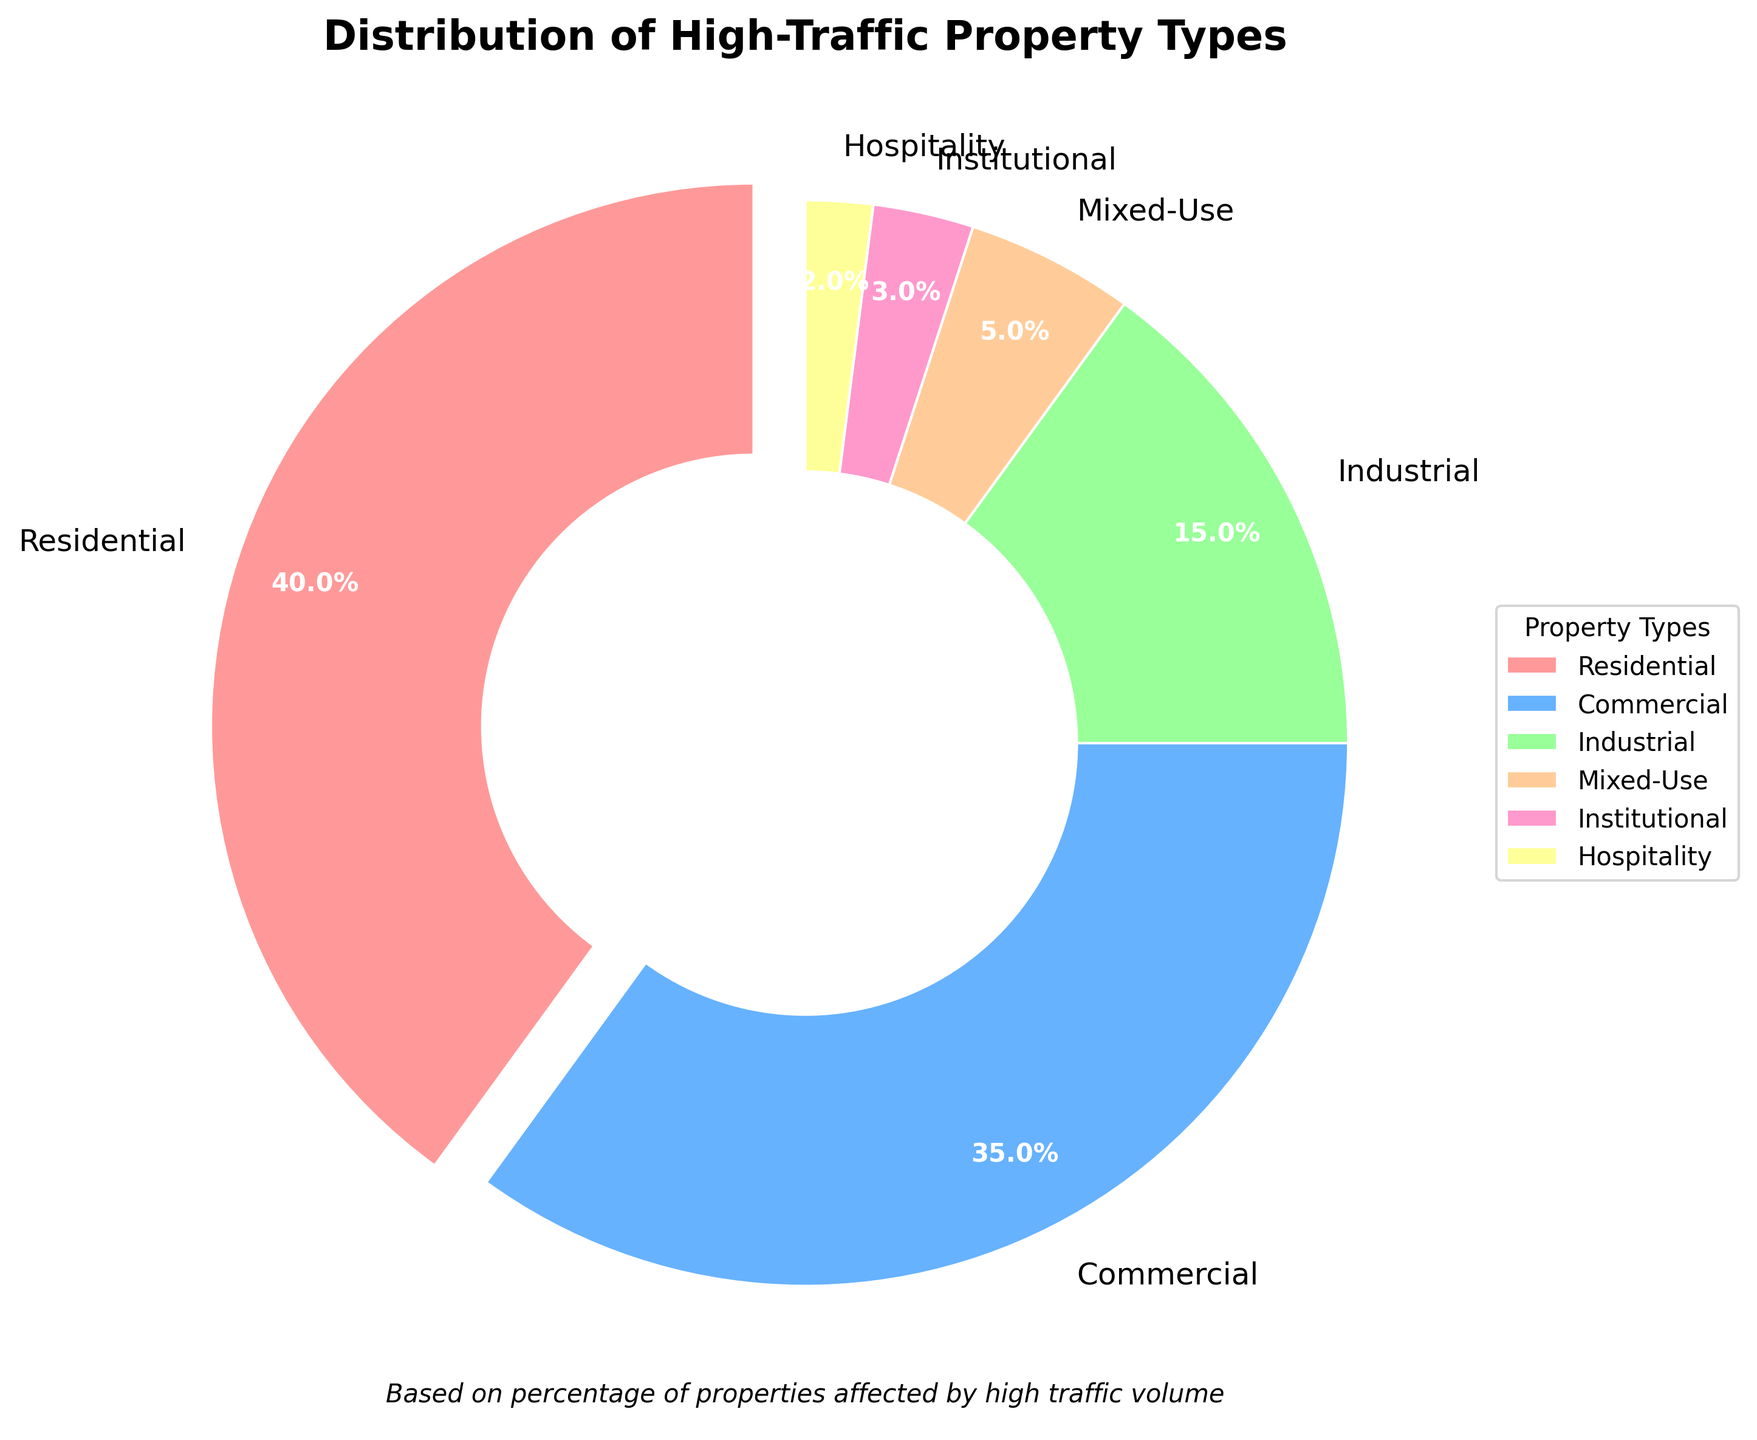What is the largest segment in the pie chart? The largest segment in the pie chart is the one with the highest percentage. By visually inspecting the figure, the segment labeled "Residential" occupies the largest area, which equals 40%.
Answer: Residential Which property type has the smallest percentage? The smallest segment on the pie chart is the one with the smallest percentage. Looking closely at the pie chart, the segment labeled "Hospitality" has the smallest size, which corresponds to 2%.
Answer: Hospitality How much greater is the percentage of Residential properties compared to Industrial properties? To find how much greater the Residential percentage is compared to Industrial, subtract the percentage of Industrial (15%) from Residential (40%). That is, 40% - 15% = 25%.
Answer: 25% What is the sum of the percentages for Commercial and Mixed-Use properties? To find the sum, add the percentage of Commercial (35%) and Mixed-Use (5%). So, 35% + 5% = 40%.
Answer: 40% Between Institutional and Hospitality properties, which has a higher percentage and by how much? Comparing the percentages for Institutional (3%) and Hospitality (2%), Institutional has a higher percentage. Subtract Hospitality's percentage from Institutional's to get the difference: 3% - 2% = 1%.
Answer: Institutional, 1% What is the percentage difference between the two leading property types? The two leading property types are Residential (40%) and Commercial (35%). Subtract the percentage of Commercial from Residential: 40% - 35% = 5%.
Answer: 5% How many property types have a percentage less than or equal to 5%? Visually inspect the pie chart for segments with percentages less than or equal to 5%. These are Mixed-Use (5%), Institutional (3%), and Hospitality (2%), giving a total of 3 property types.
Answer: 3 